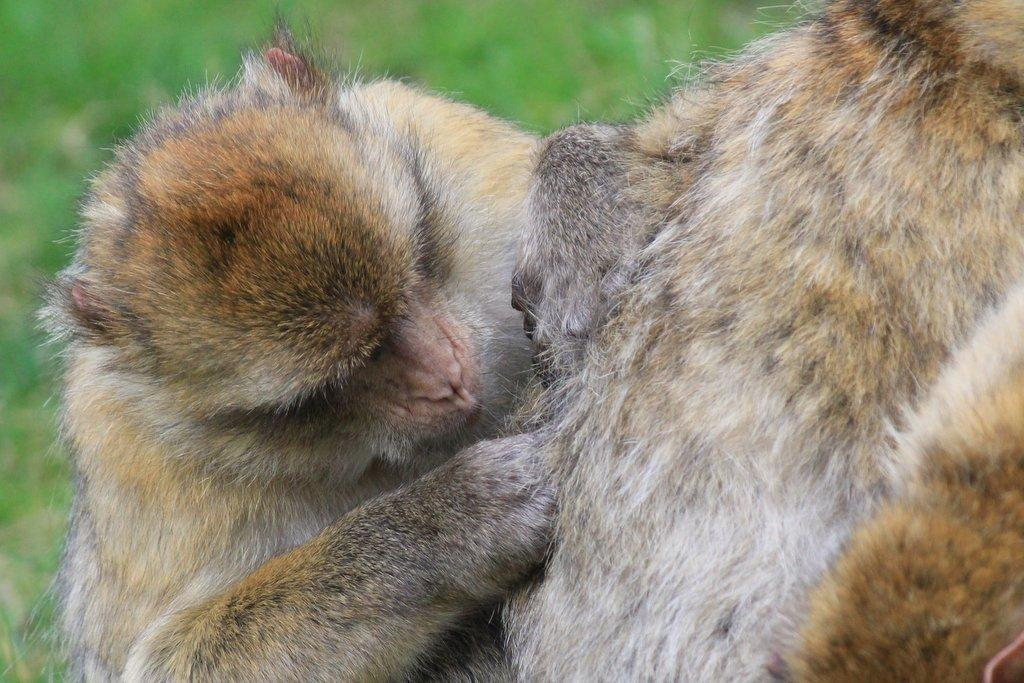What types of living organisms can be seen in the image? There are animals in the image. Can you describe the visibility of one of the animals? One animal is partially visible on the right side of the image. What color is the background of the image? The background of the image is green in color. What type of home can be seen in the image? There is no home present in the image; it features animals and a green background. How does the image provide comfort to the viewer? The image itself does not provide comfort to the viewer, as it is a static representation of animals and a background. 